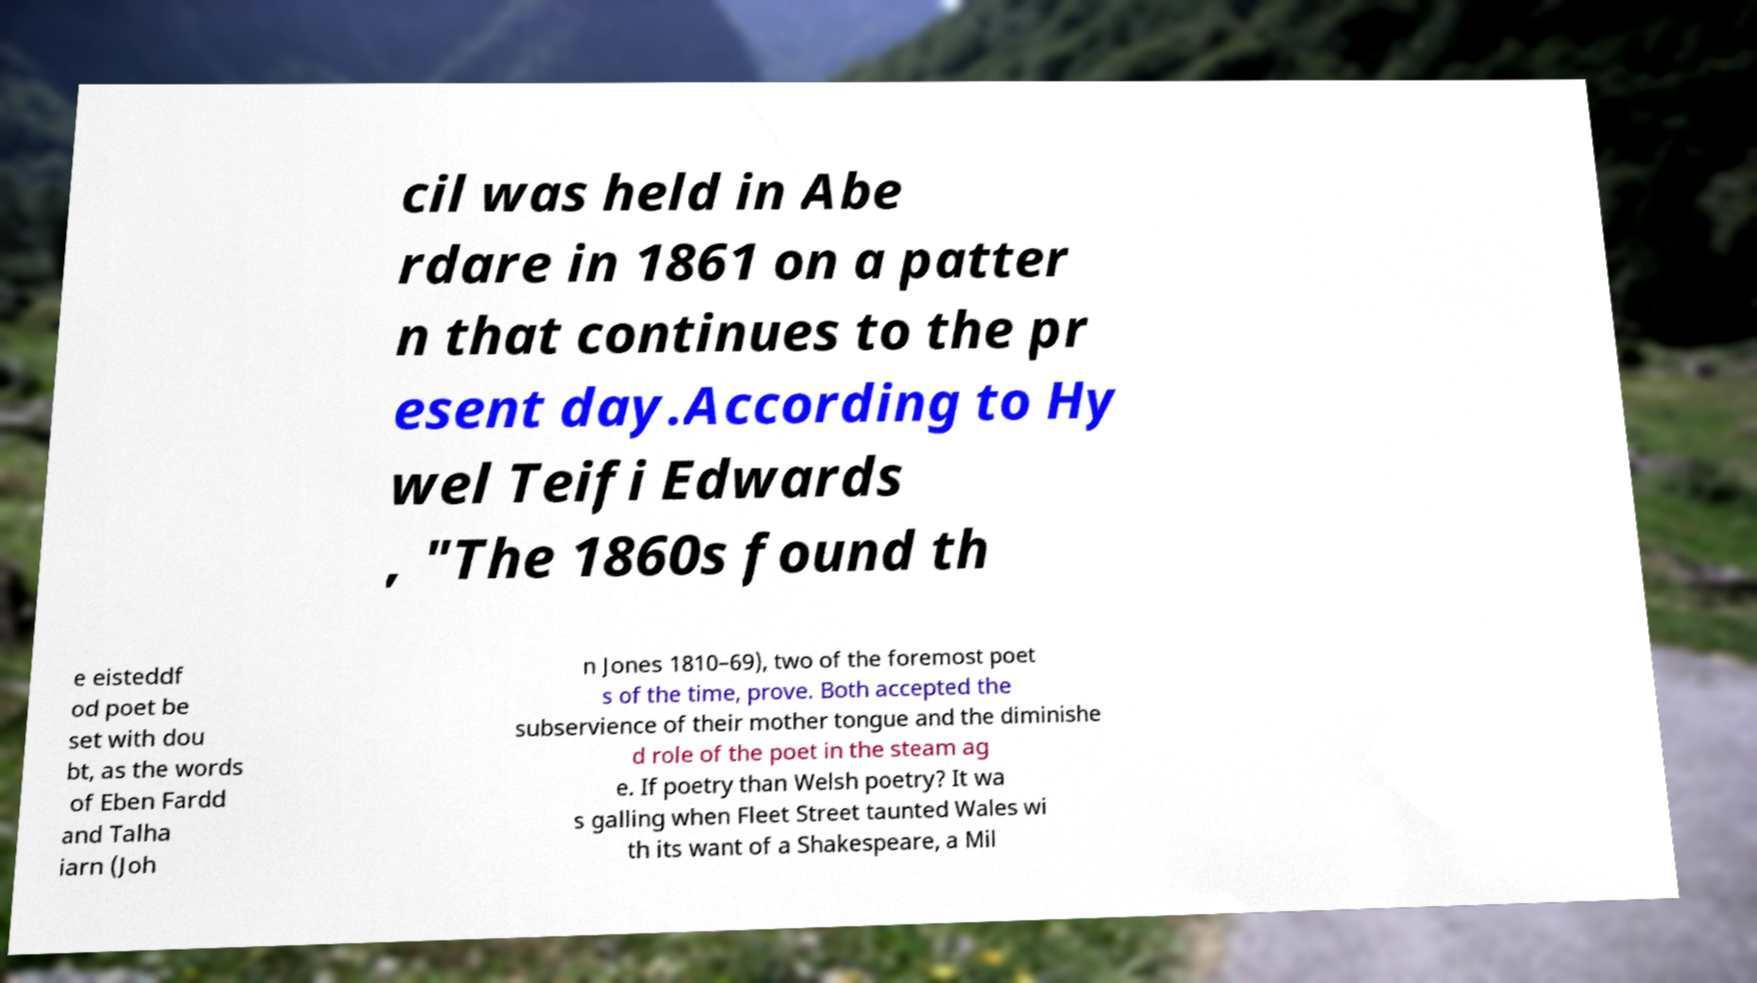Could you extract and type out the text from this image? cil was held in Abe rdare in 1861 on a patter n that continues to the pr esent day.According to Hy wel Teifi Edwards , "The 1860s found th e eisteddf od poet be set with dou bt, as the words of Eben Fardd and Talha iarn (Joh n Jones 1810–69), two of the foremost poet s of the time, prove. Both accepted the subservience of their mother tongue and the diminishe d role of the poet in the steam ag e. If poetry than Welsh poetry? It wa s galling when Fleet Street taunted Wales wi th its want of a Shakespeare, a Mil 